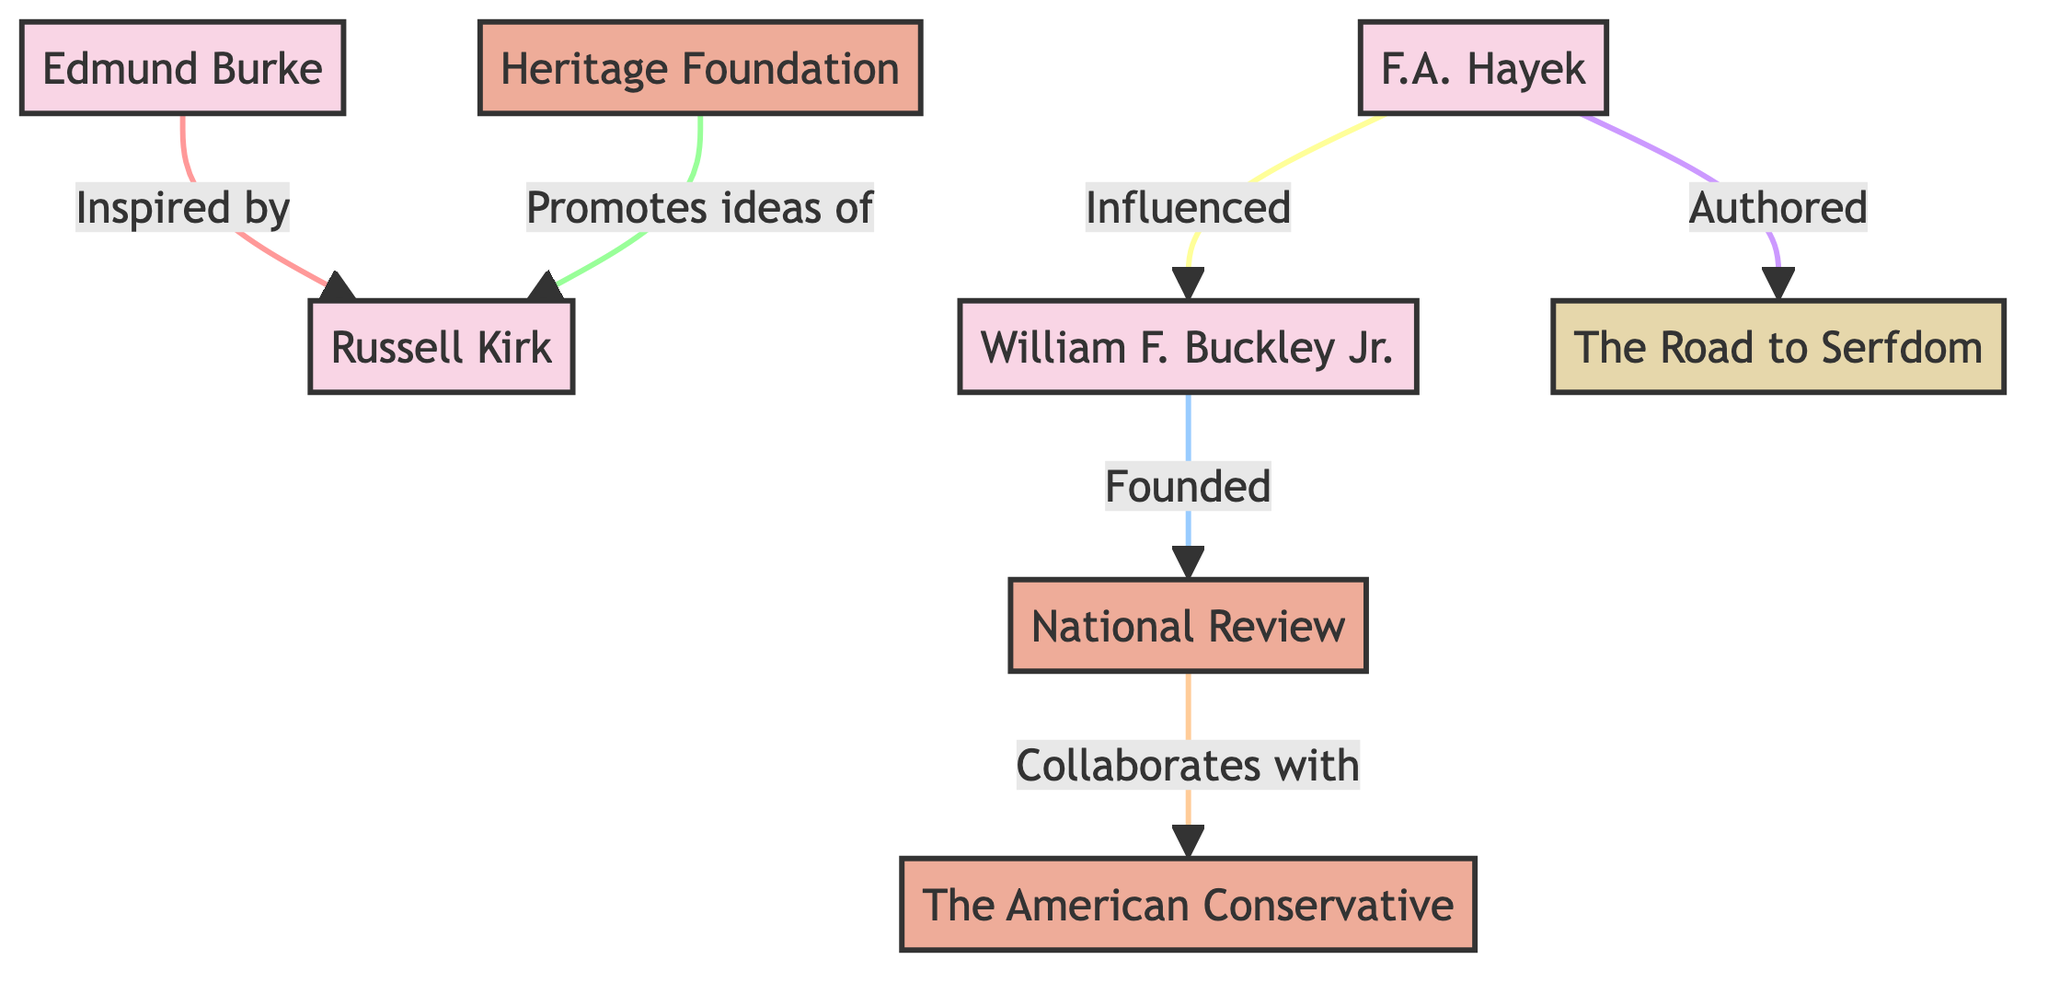What is the primary organization founded by William F. Buckley Jr.? Looking at the diagram, the node marked "National Review" is directly linked to "William F. Buckley Jr." with the label "Founded." This indicates that he is the one who founded this organization.
Answer: National Review Which key figure is inspired by Edmund Burke? The diagram shows a direct connection from the node labeled "Edmund Burke" to the node labeled "Russell Kirk," indicating that Russell Kirk is the key figure inspired by Burke.
Answer: Russell Kirk How many key figures are present in the diagram? There are four nodes labeled as key figures: "Russell Kirk," "Edmund Burke," "William F. Buckley Jr.," and "F.A. Hayek." Counting these nodes gives a total of four key figures.
Answer: 4 What is the publication authored by F.A. Hayek? The diagram links "F.A. Hayek" to the node "The Road to Serfdom" with the label "Authored," which means Hayek is the author of this publication.
Answer: The Road to Serfdom Which organization collaborates with the National Review? The arrow connecting "National Review" and "The American Conservative" is labeled "Collaborates with," indicating the collaboration between these two organizations.
Answer: The American Conservative What relationship does the Heritage Foundation have with Russell Kirk? The link between "Heritage Foundation" and "Russell Kirk" is labeled "Promotes ideas of," meaning the Heritage Foundation promotes the ideas put forth by Kirk.
Answer: Promotes ideas of How many total nodes are in the diagram? By counting all the nodes, there are a total of seven distinct nodes: four key figures, three organizations, and one publication, which sums up to eight in total.
Answer: 8 Which key figure influenced William F. Buckley Jr.? The diagram indicates a connection from "F.A. Hayek" to "William F. Buckley Jr." with the label "Influenced," suggesting that Hayek had an influence on Buckley.
Answer: F.A. Hayek 